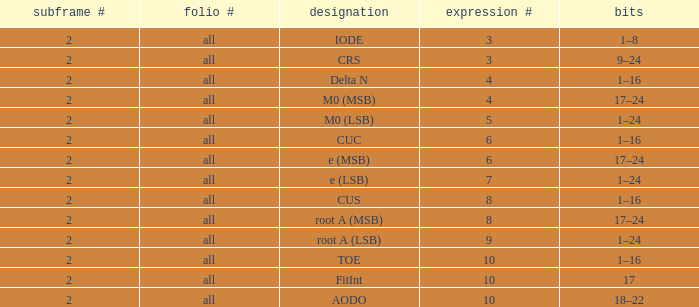What is the average word count with crs and subframes lesser than 2? None. 